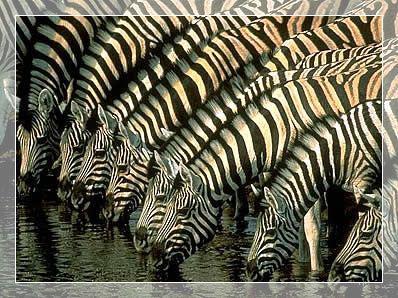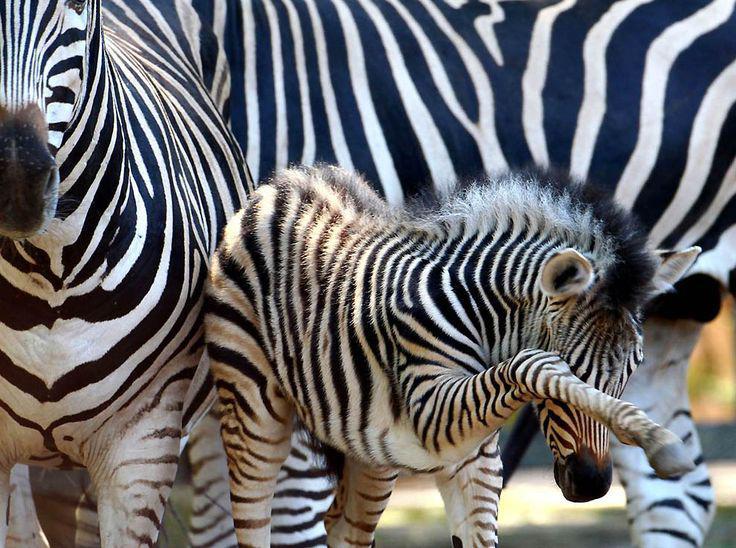The first image is the image on the left, the second image is the image on the right. Analyze the images presented: Is the assertion "The left image includes a row of leftward-facing zebras standing in water and bending their necks to drink." valid? Answer yes or no. Yes. 